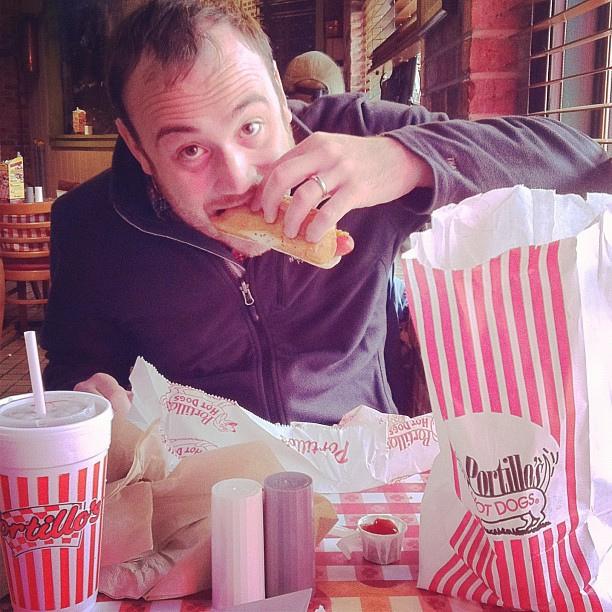Did the man prepare this food?
Short answer required. No. What is the name of the hot dog shop?
Be succinct. Portillo's. What is in the gray and white containers?
Concise answer only. Salt and pepper. 